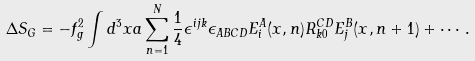<formula> <loc_0><loc_0><loc_500><loc_500>\Delta S _ { G } = - f _ { g } ^ { 2 } \int d ^ { 3 } x a \sum _ { n = 1 } ^ { N } \frac { 1 } { 4 } \epsilon ^ { i j k } \epsilon _ { A B C D } E _ { i } ^ { A } ( x , n ) R _ { k 0 } ^ { C D } E _ { j } ^ { B } ( x , n + 1 ) + \cdots .</formula> 